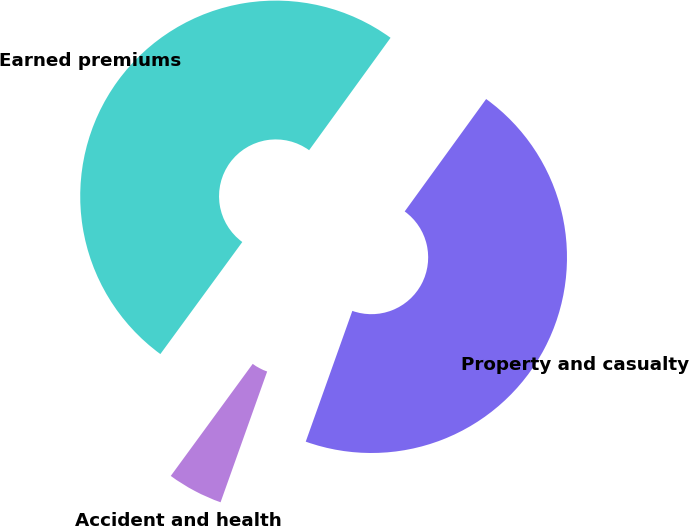Convert chart to OTSL. <chart><loc_0><loc_0><loc_500><loc_500><pie_chart><fcel>Accident and health<fcel>Earned premiums<fcel>Property and casualty<nl><fcel>4.6%<fcel>49.93%<fcel>45.47%<nl></chart> 